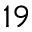Convert formula to latex. <formula><loc_0><loc_0><loc_500><loc_500>^ { 1 9 }</formula> 